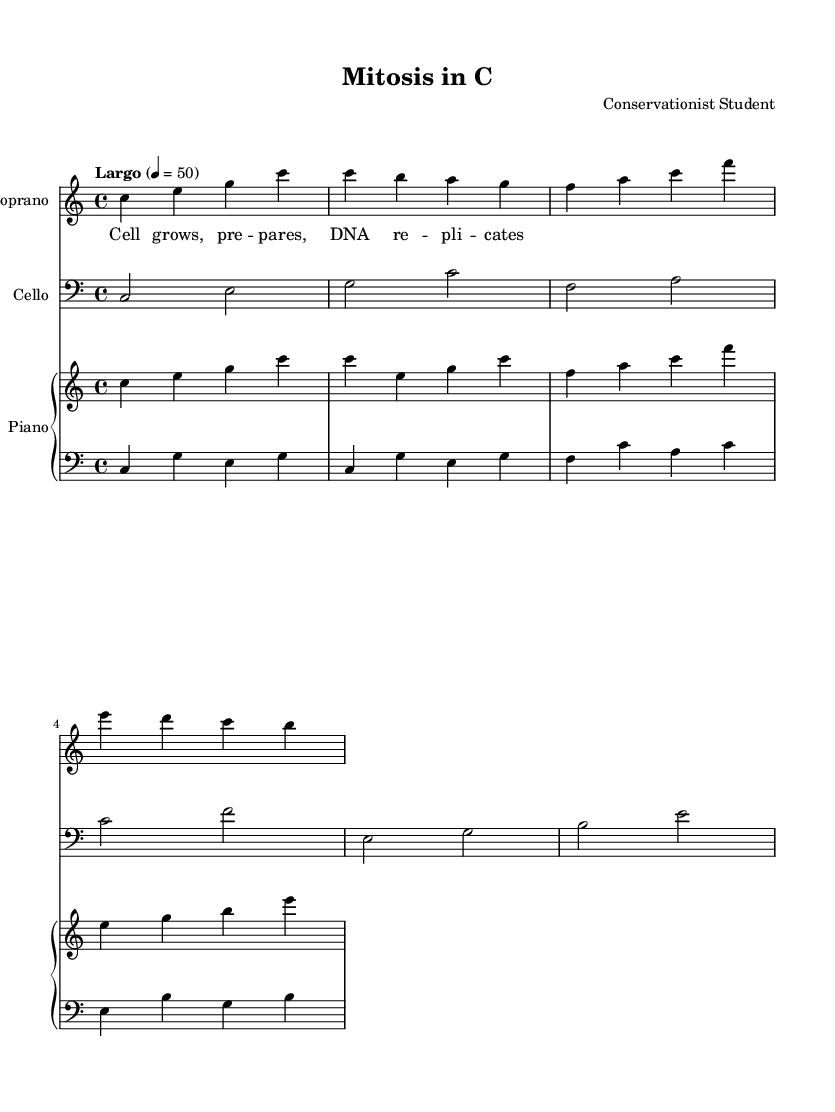What is the key signature of this music? The key signature is C major, which is indicated by the absence of sharps or flats at the beginning of the staff.
Answer: C major What is the time signature of this music? The time signature is indicated just after the clef and shows that there are four beats in each measure. This is represented by the 4/4 notation.
Answer: 4/4 What is the tempo marking for this piece? The tempo marking "Largo" is provided in the score, indicating a slow pace. Furthermore, the metronome marking of 4 = 50 reinforces this by stating the beats per minute.
Answer: Largo How many measures are in the soprano part? By counting the grouping of the notes within the soprano part, we find there are four measures present in the written notation.
Answer: 4 Which instruments are included in this score? The score contains three distinct parts: one for soprano, one for cello, and a piano part which is further divided into an upper and lower staff, indicating it has both right-hand and left-hand music.
Answer: Soprano, Cello, Piano What biological process is represented in the lyrics? The lyrics specifically mention "Cell grows, prepares, DNA replicates," which directly references the biological process of mitosis and cellular growth.
Answer: Mitosis 